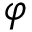Convert formula to latex. <formula><loc_0><loc_0><loc_500><loc_500>\varphi</formula> 